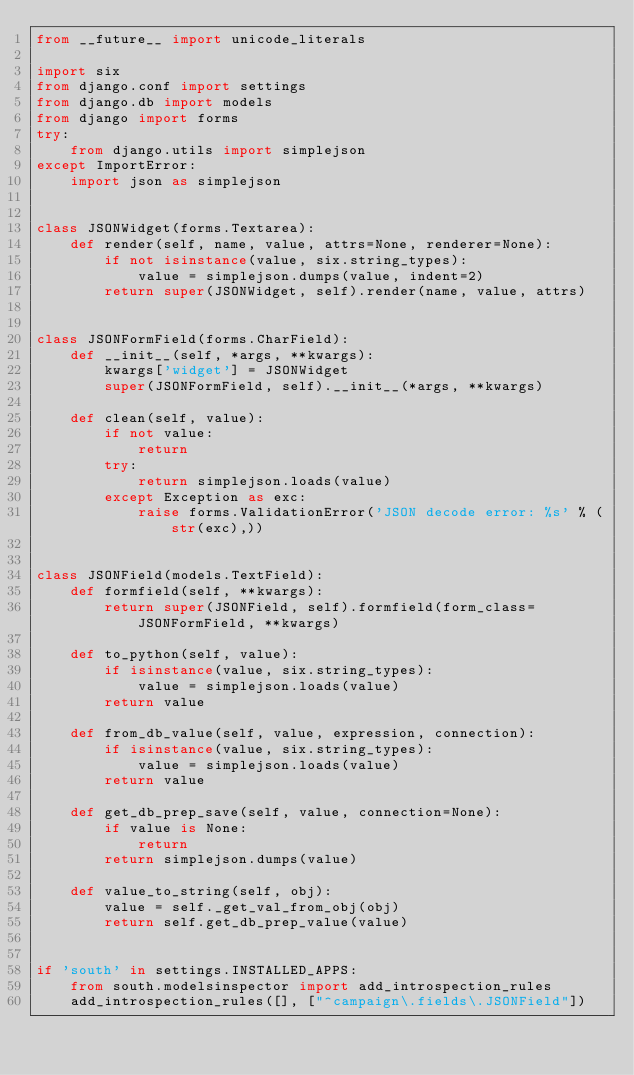Convert code to text. <code><loc_0><loc_0><loc_500><loc_500><_Python_>from __future__ import unicode_literals

import six
from django.conf import settings
from django.db import models
from django import forms
try:
    from django.utils import simplejson
except ImportError:
    import json as simplejson


class JSONWidget(forms.Textarea):
    def render(self, name, value, attrs=None, renderer=None):
        if not isinstance(value, six.string_types):
            value = simplejson.dumps(value, indent=2)
        return super(JSONWidget, self).render(name, value, attrs)


class JSONFormField(forms.CharField):
    def __init__(self, *args, **kwargs):
        kwargs['widget'] = JSONWidget
        super(JSONFormField, self).__init__(*args, **kwargs)

    def clean(self, value):
        if not value:
            return
        try:
            return simplejson.loads(value)
        except Exception as exc:
            raise forms.ValidationError('JSON decode error: %s' % (str(exc),))


class JSONField(models.TextField):
    def formfield(self, **kwargs):
        return super(JSONField, self).formfield(form_class=JSONFormField, **kwargs)

    def to_python(self, value):
        if isinstance(value, six.string_types):
            value = simplejson.loads(value)
        return value

    def from_db_value(self, value, expression, connection):
        if isinstance(value, six.string_types):
            value = simplejson.loads(value)
        return value

    def get_db_prep_save(self, value, connection=None):
        if value is None:
            return
        return simplejson.dumps(value)

    def value_to_string(self, obj):
        value = self._get_val_from_obj(obj)
        return self.get_db_prep_value(value)


if 'south' in settings.INSTALLED_APPS:
    from south.modelsinspector import add_introspection_rules
    add_introspection_rules([], ["^campaign\.fields\.JSONField"])
</code> 